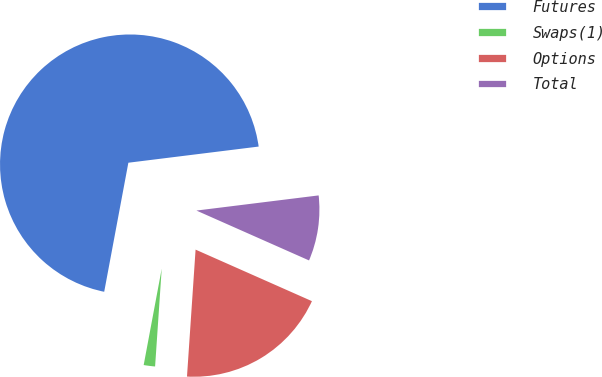Convert chart. <chart><loc_0><loc_0><loc_500><loc_500><pie_chart><fcel>Futures<fcel>Swaps(1)<fcel>Options<fcel>Total<nl><fcel>70.09%<fcel>1.87%<fcel>19.44%<fcel>8.6%<nl></chart> 